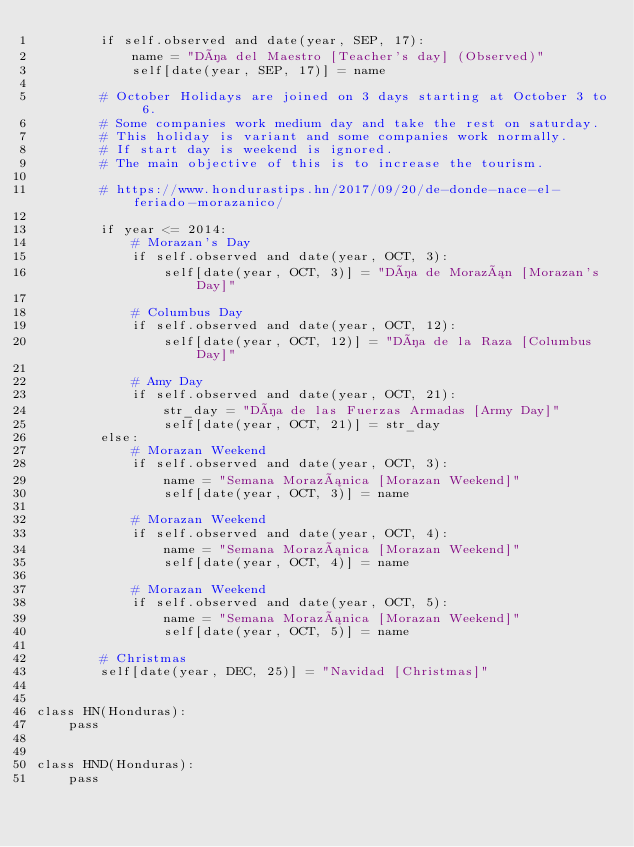Convert code to text. <code><loc_0><loc_0><loc_500><loc_500><_Python_>        if self.observed and date(year, SEP, 17):
            name = "Día del Maestro [Teacher's day] (Observed)"
            self[date(year, SEP, 17)] = name

        # October Holidays are joined on 3 days starting at October 3 to 6.
        # Some companies work medium day and take the rest on saturday.
        # This holiday is variant and some companies work normally.
        # If start day is weekend is ignored.
        # The main objective of this is to increase the tourism.

        # https://www.hondurastips.hn/2017/09/20/de-donde-nace-el-feriado-morazanico/

        if year <= 2014:
            # Morazan's Day
            if self.observed and date(year, OCT, 3):
                self[date(year, OCT, 3)] = "Día de Morazán [Morazan's Day]"

            # Columbus Day
            if self.observed and date(year, OCT, 12):
                self[date(year, OCT, 12)] = "Día de la Raza [Columbus Day]"

            # Amy Day
            if self.observed and date(year, OCT, 21):
                str_day = "Día de las Fuerzas Armadas [Army Day]"
                self[date(year, OCT, 21)] = str_day
        else:
            # Morazan Weekend
            if self.observed and date(year, OCT, 3):
                name = "Semana Morazánica [Morazan Weekend]"
                self[date(year, OCT, 3)] = name

            # Morazan Weekend
            if self.observed and date(year, OCT, 4):
                name = "Semana Morazánica [Morazan Weekend]"
                self[date(year, OCT, 4)] = name

            # Morazan Weekend
            if self.observed and date(year, OCT, 5):
                name = "Semana Morazánica [Morazan Weekend]"
                self[date(year, OCT, 5)] = name

        # Christmas
        self[date(year, DEC, 25)] = "Navidad [Christmas]"


class HN(Honduras):
    pass


class HND(Honduras):
    pass
</code> 